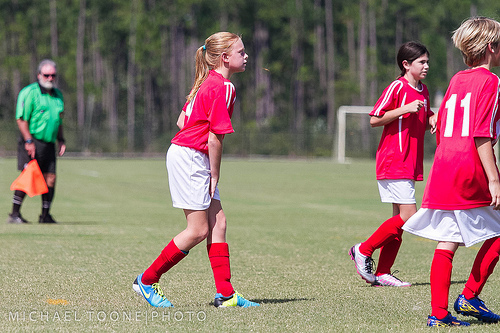<image>
Is there a flag on the person? Yes. Looking at the image, I can see the flag is positioned on top of the person, with the person providing support. Where is the robot in relation to the factory? Is it in front of the factory? No. The robot is not in front of the factory. The spatial positioning shows a different relationship between these objects. 